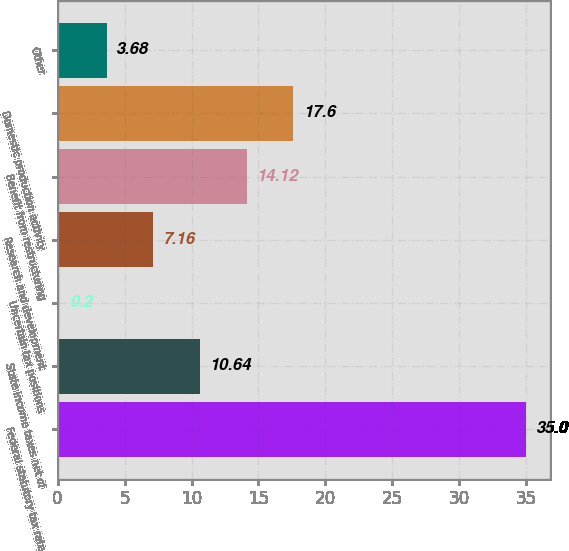<chart> <loc_0><loc_0><loc_500><loc_500><bar_chart><fcel>Federal statutory tax rate<fcel>State income taxes net of<fcel>Uncertain tax positions<fcel>Research and development<fcel>Benefit from restructuring<fcel>Domestic production activity<fcel>Other<nl><fcel>35<fcel>10.64<fcel>0.2<fcel>7.16<fcel>14.12<fcel>17.6<fcel>3.68<nl></chart> 